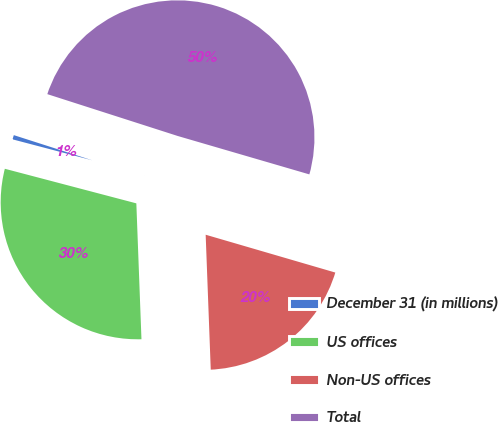Convert chart. <chart><loc_0><loc_0><loc_500><loc_500><pie_chart><fcel>December 31 (in millions)<fcel>US offices<fcel>Non-US offices<fcel>Total<nl><fcel>0.85%<fcel>29.69%<fcel>19.88%<fcel>49.57%<nl></chart> 